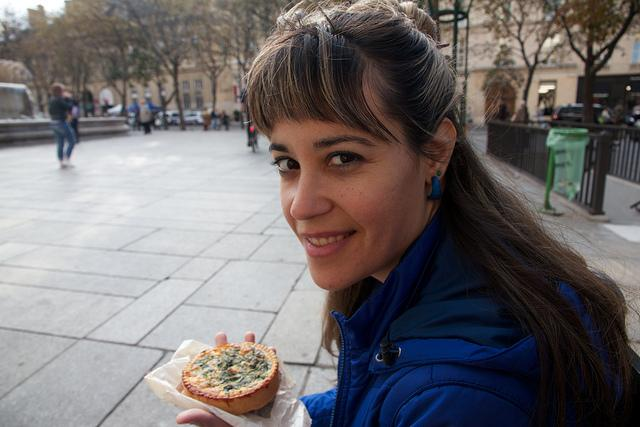What is matching the color of her jacket? Please explain your reasoning. earrings. They are both blue 